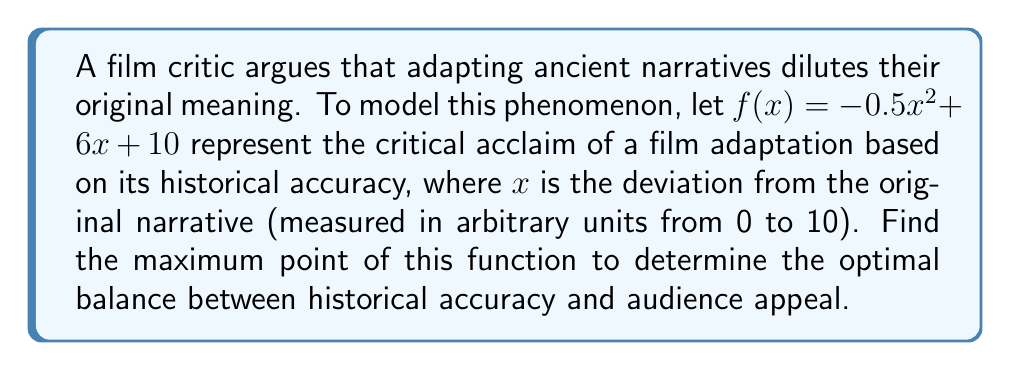Could you help me with this problem? To find the maximum point of the function $f(x) = -0.5x^2 + 6x + 10$, we need to follow these steps:

1) First, we need to find the derivative of the function:
   $$f'(x) = -x + 6$$

2) To find the critical point, set the derivative equal to zero and solve for x:
   $$-x + 6 = 0$$
   $$x = 6$$

3) To confirm this is a maximum point, we can check the second derivative:
   $$f''(x) = -1$$
   Since $f''(x)$ is negative for all x, the critical point is indeed a maximum.

4) To find the y-coordinate of the maximum point, we plug x = 6 into the original function:
   $$f(6) = -0.5(6)^2 + 6(6) + 10$$
   $$= -18 + 36 + 10$$
   $$= 28$$

5) Therefore, the maximum point occurs at (6, 28).

This result suggests that the optimal balance between historical accuracy and audience appeal occurs when the deviation from the original narrative is 6 units, resulting in a critical acclaim score of 28.
Answer: The maximum point of the function occurs at (6, 28). 